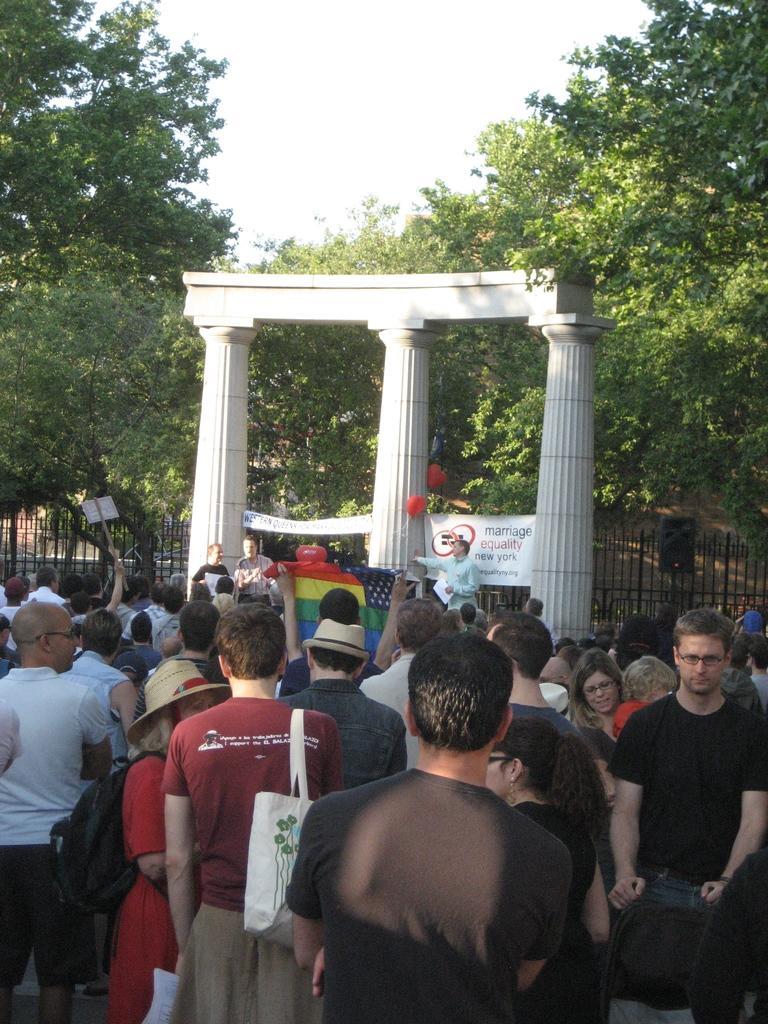Could you give a brief overview of what you see in this image? Here there are few people standing on the road and here a person carrying a bag on his shoulder. In the background we can see hoarding,banner,balloons,trees,fence,cloth,some other items and sky 